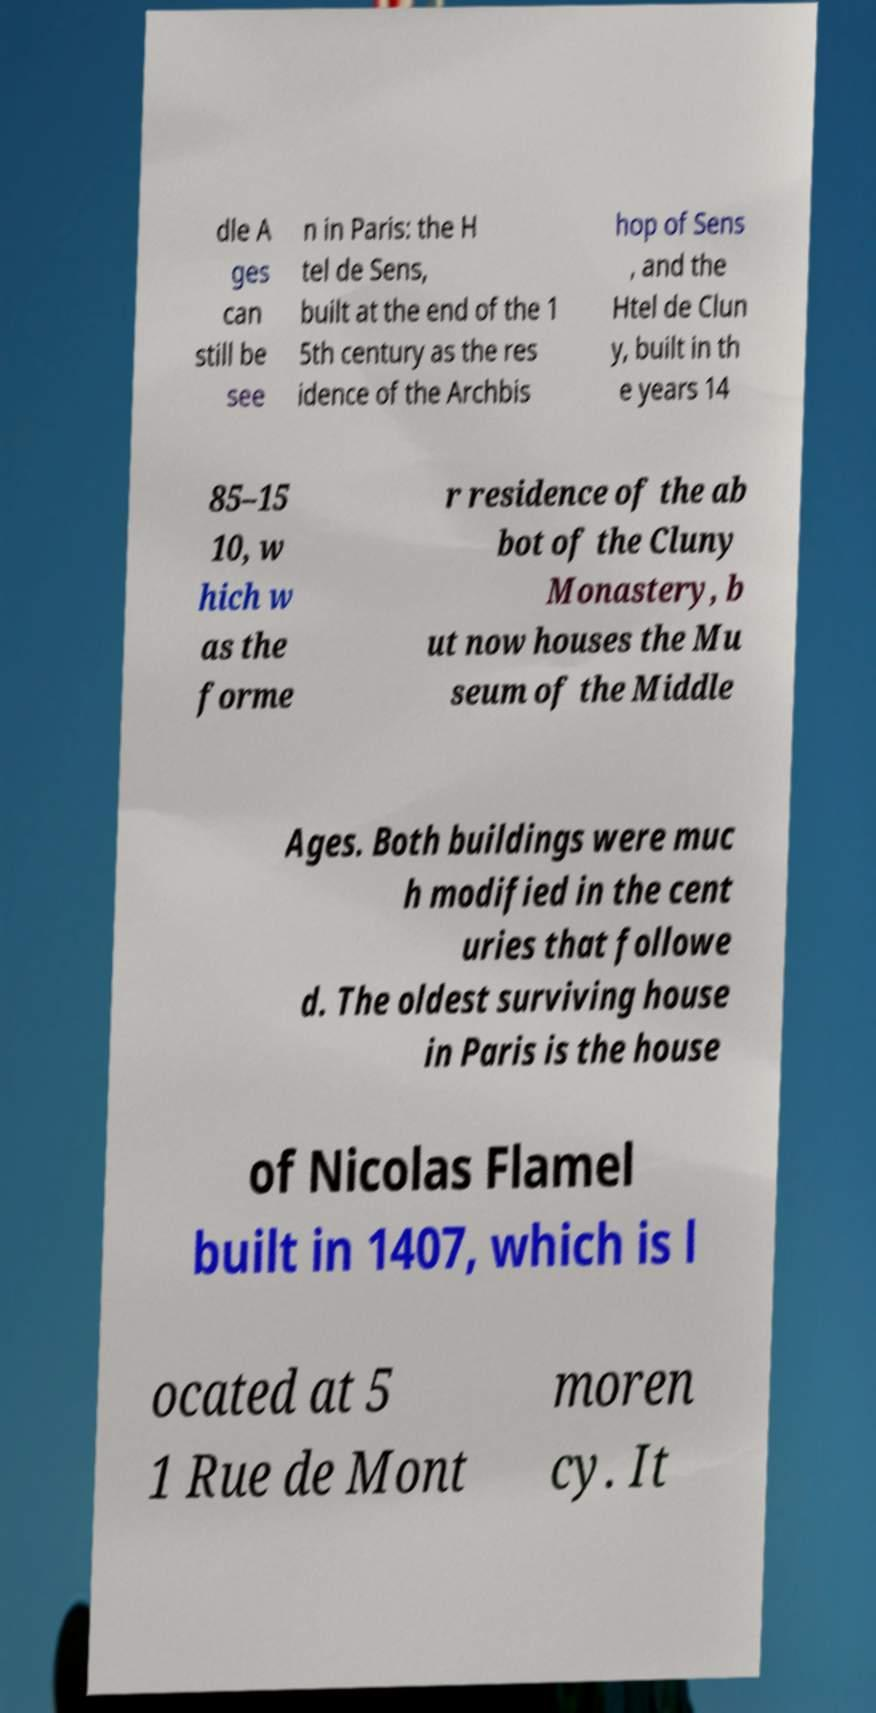Can you read and provide the text displayed in the image?This photo seems to have some interesting text. Can you extract and type it out for me? dle A ges can still be see n in Paris: the H tel de Sens, built at the end of the 1 5th century as the res idence of the Archbis hop of Sens , and the Htel de Clun y, built in th e years 14 85–15 10, w hich w as the forme r residence of the ab bot of the Cluny Monastery, b ut now houses the Mu seum of the Middle Ages. Both buildings were muc h modified in the cent uries that followe d. The oldest surviving house in Paris is the house of Nicolas Flamel built in 1407, which is l ocated at 5 1 Rue de Mont moren cy. It 